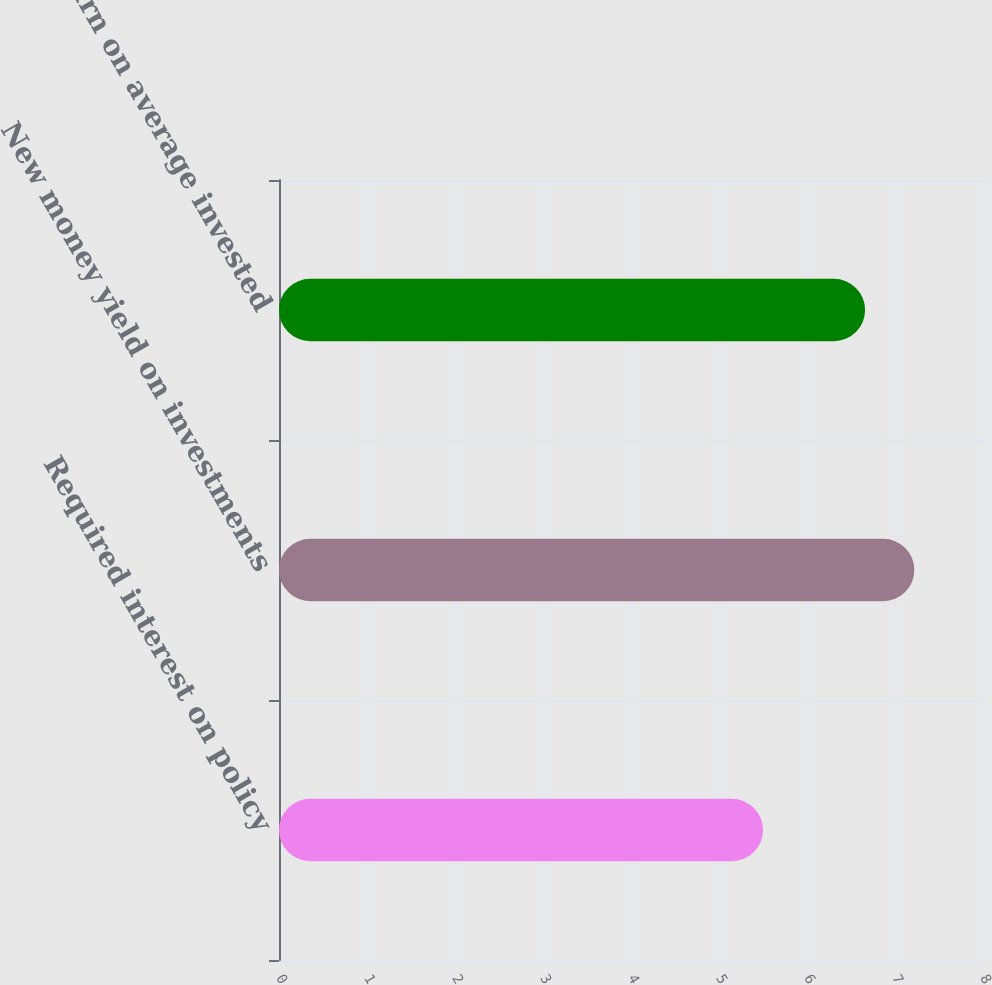<chart> <loc_0><loc_0><loc_500><loc_500><bar_chart><fcel>Required interest on policy<fcel>New money yield on investments<fcel>Return on average invested<nl><fcel>5.5<fcel>7.22<fcel>6.66<nl></chart> 